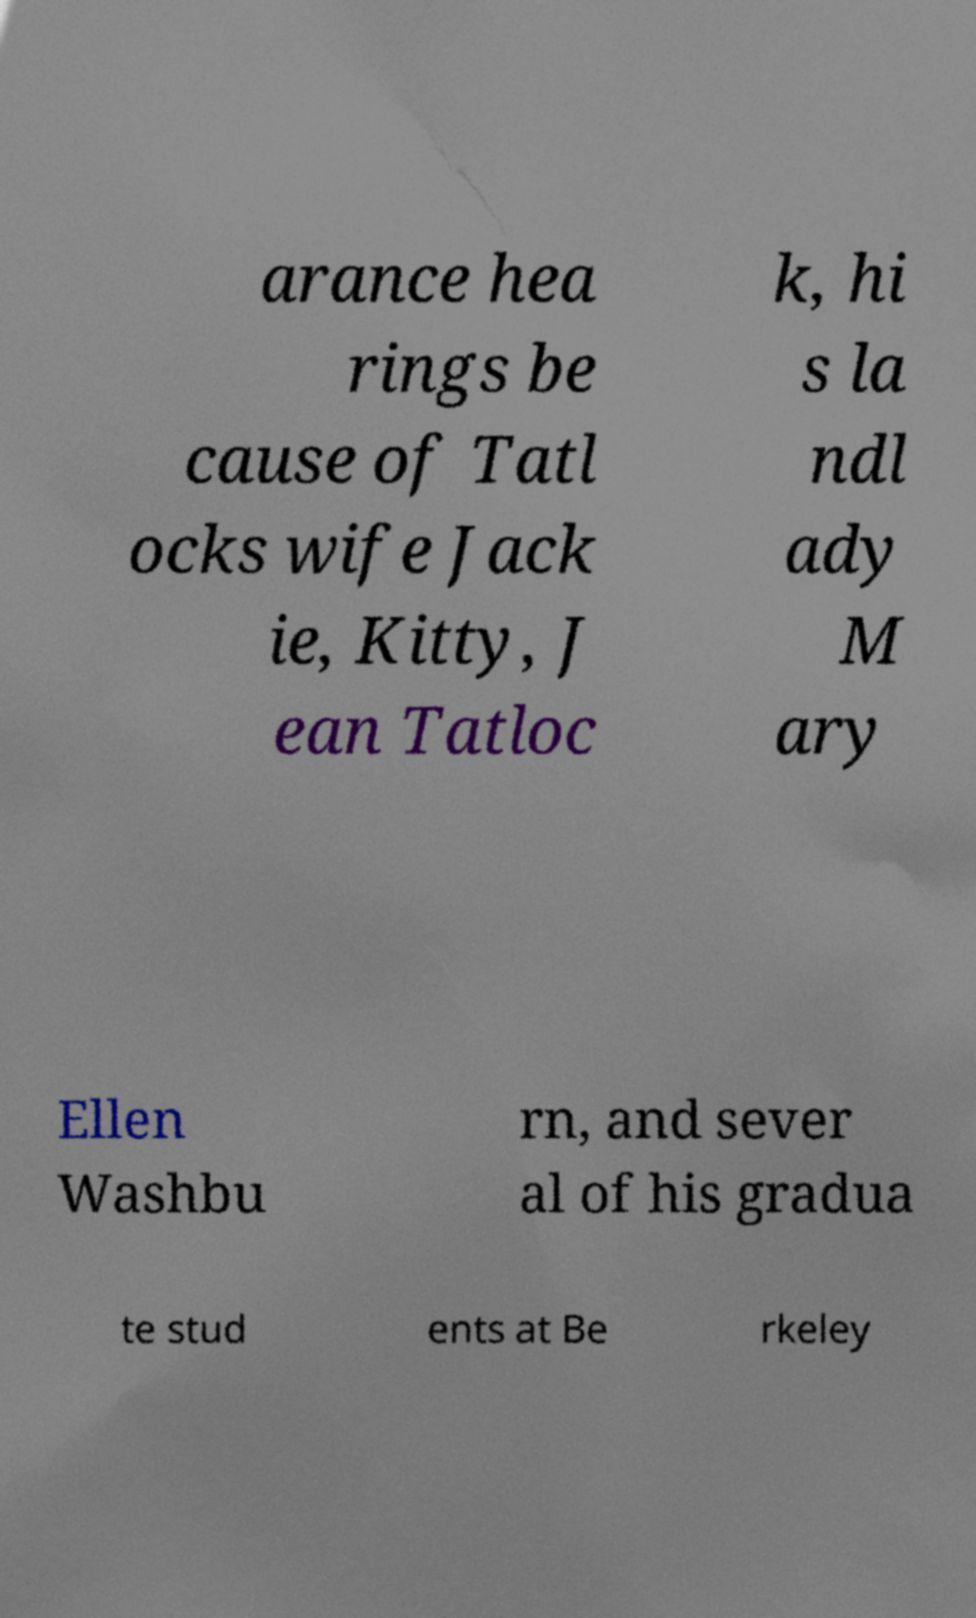Can you accurately transcribe the text from the provided image for me? arance hea rings be cause of Tatl ocks wife Jack ie, Kitty, J ean Tatloc k, hi s la ndl ady M ary Ellen Washbu rn, and sever al of his gradua te stud ents at Be rkeley 